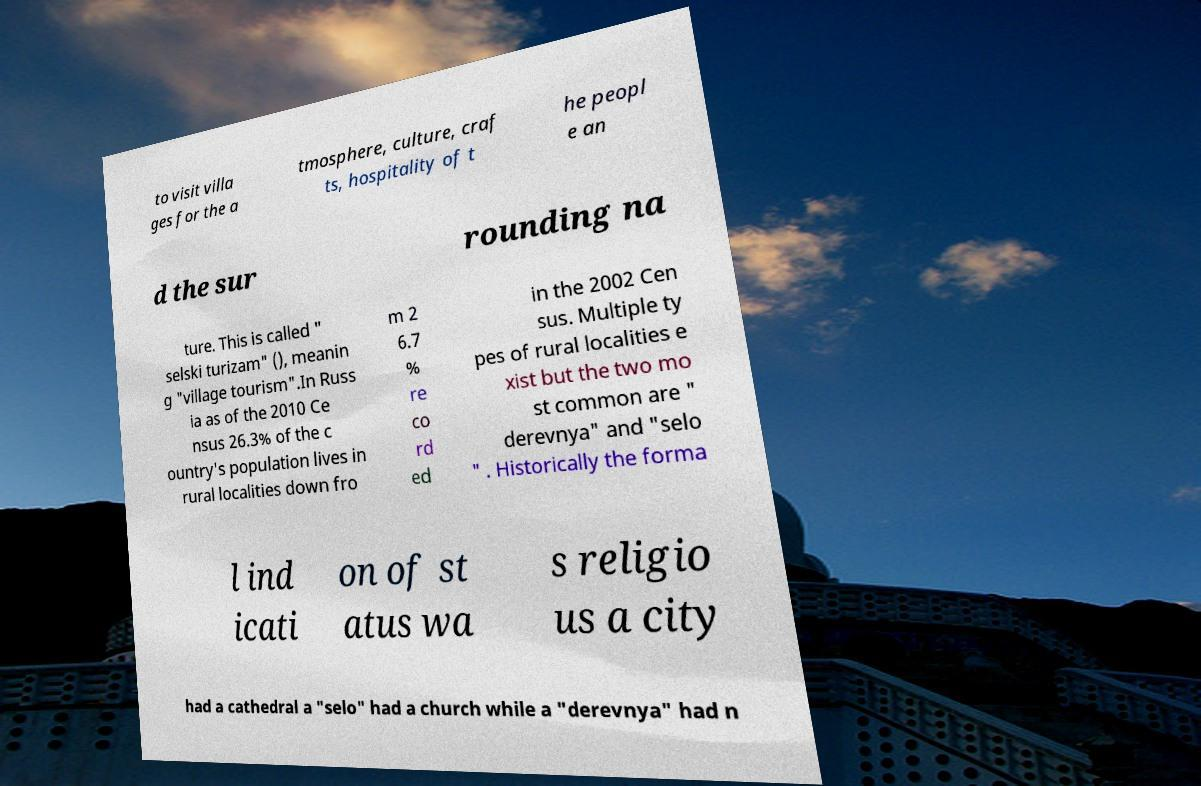Could you assist in decoding the text presented in this image and type it out clearly? to visit villa ges for the a tmosphere, culture, craf ts, hospitality of t he peopl e an d the sur rounding na ture. This is called " selski turizam" (), meanin g "village tourism".In Russ ia as of the 2010 Ce nsus 26.3% of the c ountry's population lives in rural localities down fro m 2 6.7 % re co rd ed in the 2002 Cen sus. Multiple ty pes of rural localities e xist but the two mo st common are " derevnya" and "selo " . Historically the forma l ind icati on of st atus wa s religio us a city had a cathedral a "selo" had a church while a "derevnya" had n 